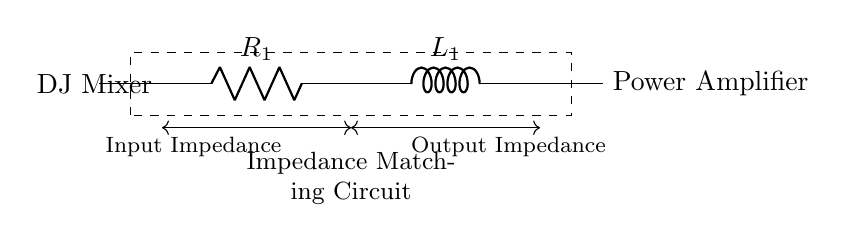What components are present in this circuit? The circuit has a resistor labeled R1 and an inductor labeled L1, which are connected in series between the DJ Mixer and the Power Amplifier.
Answer: Resistor and Inductor What is the function of the circuit? The circuit serves as an impedance matching circuit to connect the DJ mixer to a power amplifier, ensuring efficient power transfer and minimizing signal reflection.
Answer: Impedance matching What is the relationship between input and output impedance? The input impedance of the circuit is determined by the resistor and inductor combination, while the output impedance is tailored to match the power amplifier’s specifications, thus allowing for effective impedance matching.
Answer: Matched What type of circuit configuration is this? The configuration consists of a resistor in series with an inductor, which is a common arrangement in impedance matching circuits.
Answer: Series configuration How does the inductor affect the impedance? The inductor introduces inductive reactance into the circuit, which varies with frequency, allowing it to adjust the overall impedance and improve matching over a range of frequencies.
Answer: Adjusts impedance What is the significance of using a resistor in this circuit? The resistor helps to dissipate energy, stabilizes the circuit, and can be used to set the desired impedance level for matching with the DJ mixer or power amplifier.
Answer: Stabilizes and sets impedance What happens to signal integrity if the impedance is not matched? If the impedance is not matched, it results in signal reflection, loss of power, and potential distortion of the audio signal, degrading overall sound quality.
Answer: Signal loss and distortion 